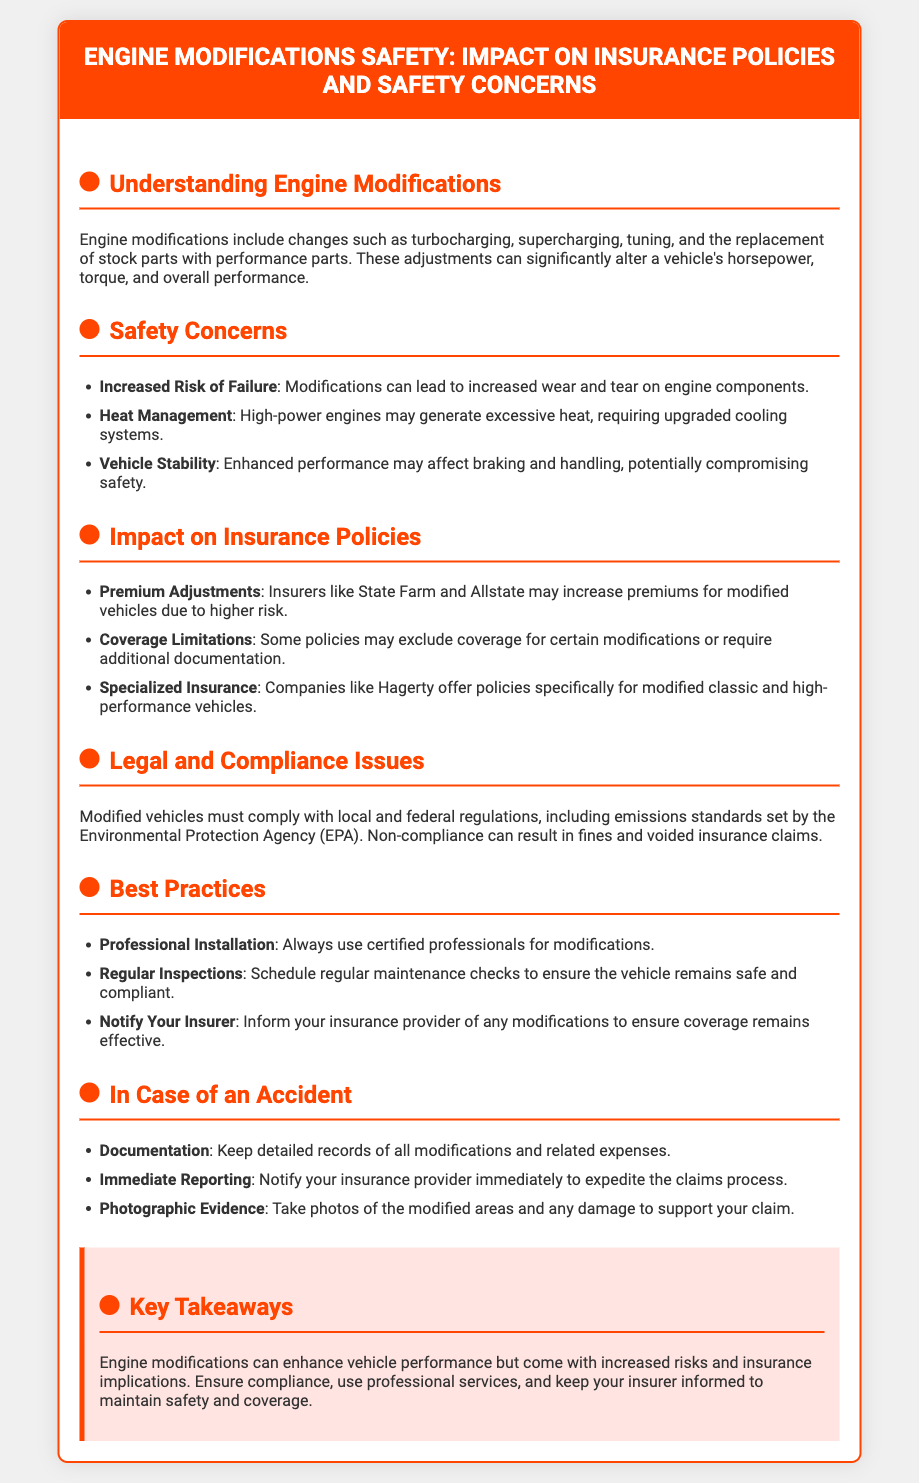What are engine modifications? Engine modifications include changes such as turbocharging, supercharging, tuning, and the replacement of stock parts with performance parts.
Answer: Changes like turbocharging, supercharging, and tuning What is a safety concern related to engine modifications? One safety concern mentioned is increased risk of failure due to wear and tear on engine components.
Answer: Increased risk of failure Which insurance companies may increase premiums for modified vehicles? The document lists State Farm and Allstate as insurers that may increase premiums.
Answer: State Farm and Allstate What is required for some insurance policies regarding modifications? Some policies may require additional documentation for certain modifications.
Answer: Additional documentation What should you do after making engine modifications? You should notify your insurance provider of any modifications.
Answer: Notify your insurer What type of coverage is available for modified classic vehicles? Companies like Hagerty offer specialized insurance for modified classic and high-performance vehicles.
Answer: Specialized insurance What is a key takeaway regarding engine modifications? A key takeaway is to ensure compliance and keep your insurer informed to maintain safety and coverage.
Answer: Ensure compliance and notify your insurer What must modified vehicles comply with? Modified vehicles must comply with local and federal regulations, including emissions standards set by the Environmental Protection Agency (EPA).
Answer: Local and federal regulations, including EPA standards What should you do during regular maintenance checks? Regular inspections should be scheduled to ensure the vehicle remains safe and compliant.
Answer: Schedule regular inspections 